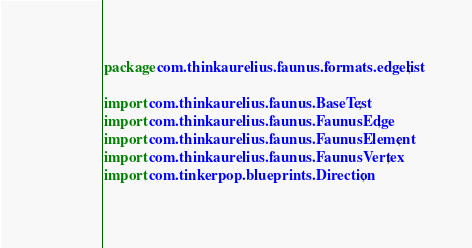<code> <loc_0><loc_0><loc_500><loc_500><_Java_>package com.thinkaurelius.faunus.formats.edgelist;

import com.thinkaurelius.faunus.BaseTest;
import com.thinkaurelius.faunus.FaunusEdge;
import com.thinkaurelius.faunus.FaunusElement;
import com.thinkaurelius.faunus.FaunusVertex;
import com.tinkerpop.blueprints.Direction;</code> 